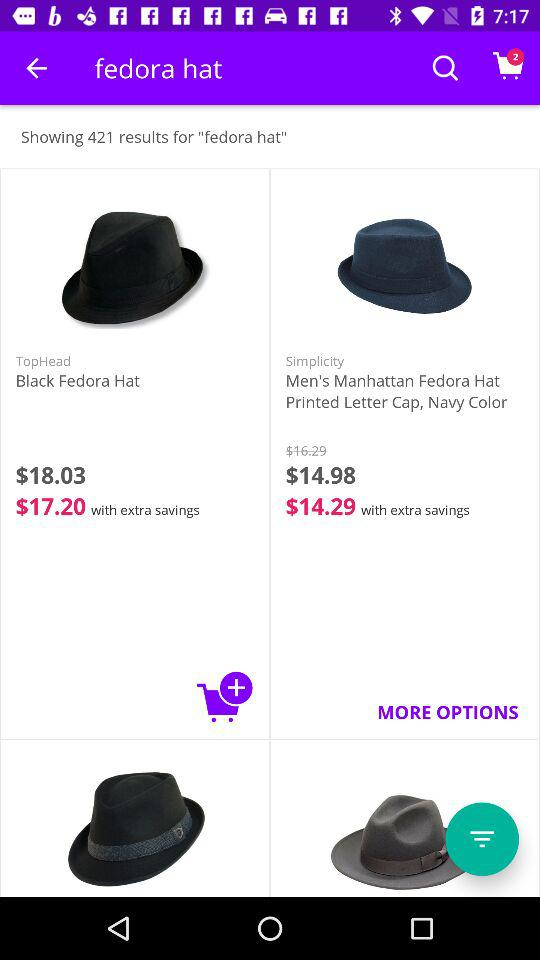What is the price of the black fedora hat? The prices are $18.03 and $17.20. 